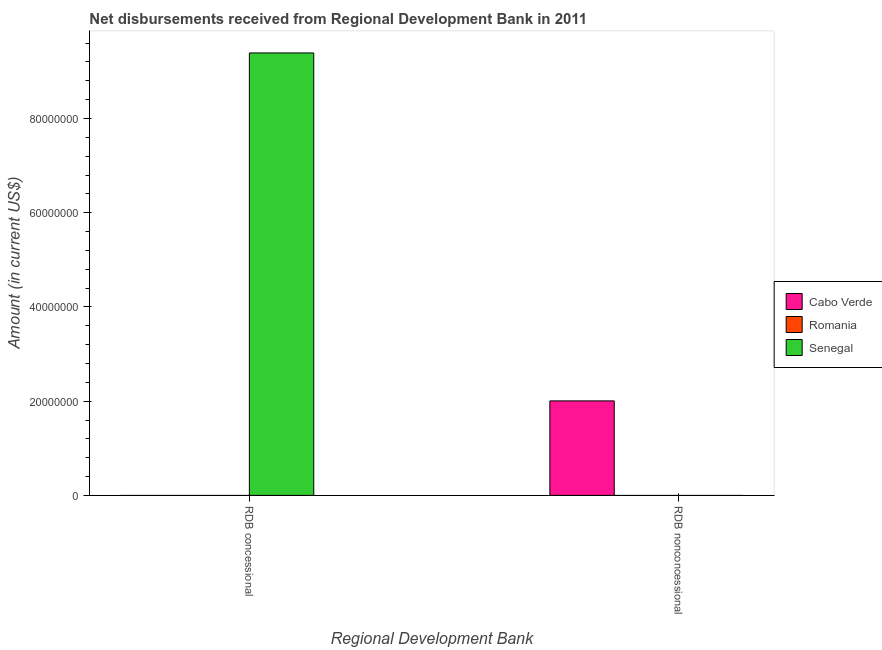Are the number of bars per tick equal to the number of legend labels?
Make the answer very short. No. Are the number of bars on each tick of the X-axis equal?
Ensure brevity in your answer.  Yes. How many bars are there on the 2nd tick from the left?
Offer a very short reply. 1. What is the label of the 2nd group of bars from the left?
Your answer should be very brief. RDB nonconcessional. What is the net concessional disbursements from rdb in Cabo Verde?
Offer a very short reply. 0. Across all countries, what is the maximum net non concessional disbursements from rdb?
Provide a succinct answer. 2.01e+07. In which country was the net concessional disbursements from rdb maximum?
Provide a short and direct response. Senegal. What is the total net non concessional disbursements from rdb in the graph?
Offer a terse response. 2.01e+07. What is the difference between the net non concessional disbursements from rdb in Cabo Verde and the net concessional disbursements from rdb in Romania?
Your answer should be very brief. 2.01e+07. What is the average net non concessional disbursements from rdb per country?
Keep it short and to the point. 6.68e+06. In how many countries, is the net concessional disbursements from rdb greater than 68000000 US$?
Provide a succinct answer. 1. In how many countries, is the net concessional disbursements from rdb greater than the average net concessional disbursements from rdb taken over all countries?
Provide a short and direct response. 1. How many bars are there?
Offer a terse response. 2. How many countries are there in the graph?
Ensure brevity in your answer.  3. Are the values on the major ticks of Y-axis written in scientific E-notation?
Your answer should be very brief. No. Does the graph contain grids?
Keep it short and to the point. No. Where does the legend appear in the graph?
Your response must be concise. Center right. What is the title of the graph?
Make the answer very short. Net disbursements received from Regional Development Bank in 2011. What is the label or title of the X-axis?
Offer a terse response. Regional Development Bank. What is the label or title of the Y-axis?
Give a very brief answer. Amount (in current US$). What is the Amount (in current US$) of Cabo Verde in RDB concessional?
Ensure brevity in your answer.  0. What is the Amount (in current US$) of Romania in RDB concessional?
Ensure brevity in your answer.  0. What is the Amount (in current US$) in Senegal in RDB concessional?
Ensure brevity in your answer.  9.39e+07. What is the Amount (in current US$) of Cabo Verde in RDB nonconcessional?
Ensure brevity in your answer.  2.01e+07. What is the Amount (in current US$) in Senegal in RDB nonconcessional?
Ensure brevity in your answer.  0. Across all Regional Development Bank, what is the maximum Amount (in current US$) in Cabo Verde?
Ensure brevity in your answer.  2.01e+07. Across all Regional Development Bank, what is the maximum Amount (in current US$) of Senegal?
Offer a very short reply. 9.39e+07. Across all Regional Development Bank, what is the minimum Amount (in current US$) in Cabo Verde?
Your response must be concise. 0. Across all Regional Development Bank, what is the minimum Amount (in current US$) in Senegal?
Your response must be concise. 0. What is the total Amount (in current US$) in Cabo Verde in the graph?
Keep it short and to the point. 2.01e+07. What is the total Amount (in current US$) in Romania in the graph?
Offer a terse response. 0. What is the total Amount (in current US$) of Senegal in the graph?
Give a very brief answer. 9.39e+07. What is the average Amount (in current US$) of Cabo Verde per Regional Development Bank?
Your answer should be compact. 1.00e+07. What is the average Amount (in current US$) of Romania per Regional Development Bank?
Offer a very short reply. 0. What is the average Amount (in current US$) in Senegal per Regional Development Bank?
Your answer should be compact. 4.70e+07. What is the difference between the highest and the lowest Amount (in current US$) in Cabo Verde?
Make the answer very short. 2.01e+07. What is the difference between the highest and the lowest Amount (in current US$) of Senegal?
Offer a very short reply. 9.39e+07. 